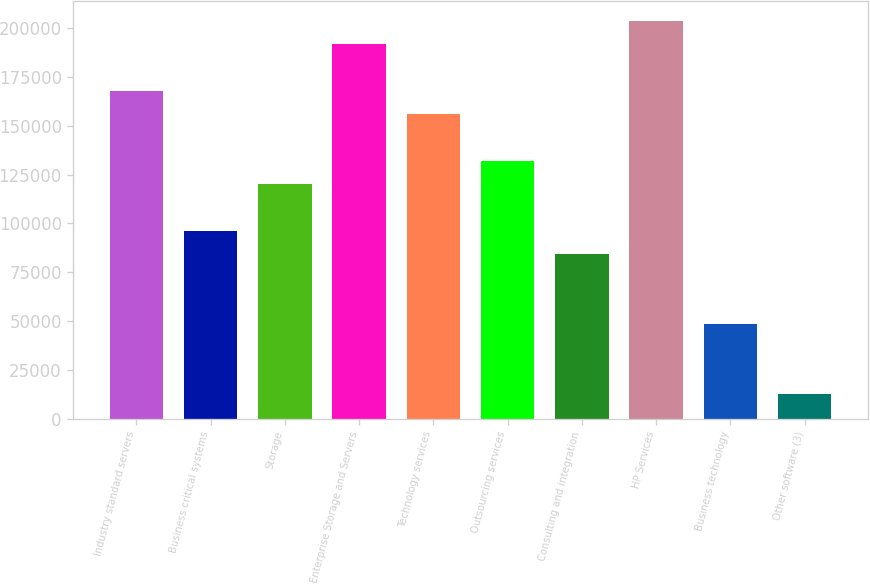Convert chart to OTSL. <chart><loc_0><loc_0><loc_500><loc_500><bar_chart><fcel>Industry standard servers<fcel>Business critical systems<fcel>Storage<fcel>Enterprise Storage and Servers<fcel>Technology services<fcel>Outsourcing services<fcel>Consulting and integration<fcel>HP Services<fcel>Business technology<fcel>Other software (3)<nl><fcel>168093<fcel>96207.2<fcel>120169<fcel>192054<fcel>156112<fcel>132150<fcel>84226.3<fcel>204035<fcel>48283.6<fcel>12340.9<nl></chart> 